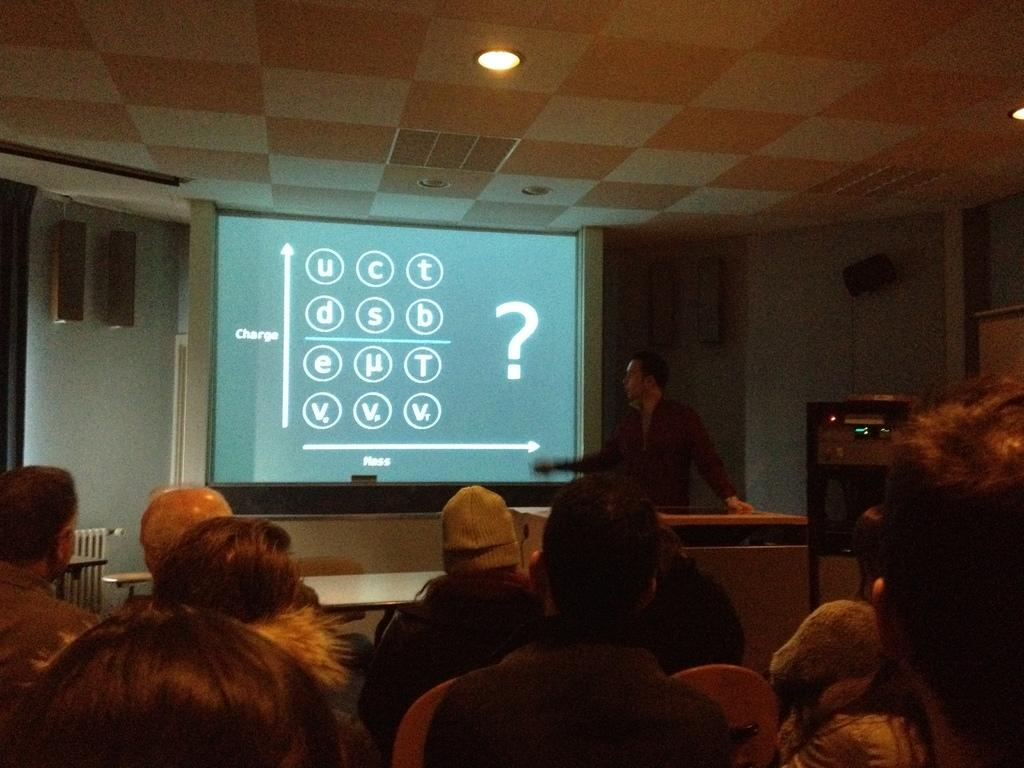What are the people in the image doing? There is a group of people sitting in the image. Can you describe the person in the background? There is a person standing in the background of the image. What is the main object in the image? There is a projection screen in the image. What can be seen on the projection screen? The content on the projection screen cannot be determined from the provided facts. What color is the wall in the image? The wall is white in color. How many volcanoes are visible in the image? There are no volcanoes present in the image. Are the people in the image sisters? The relationship between the people in the image cannot be determined from the provided facts. 